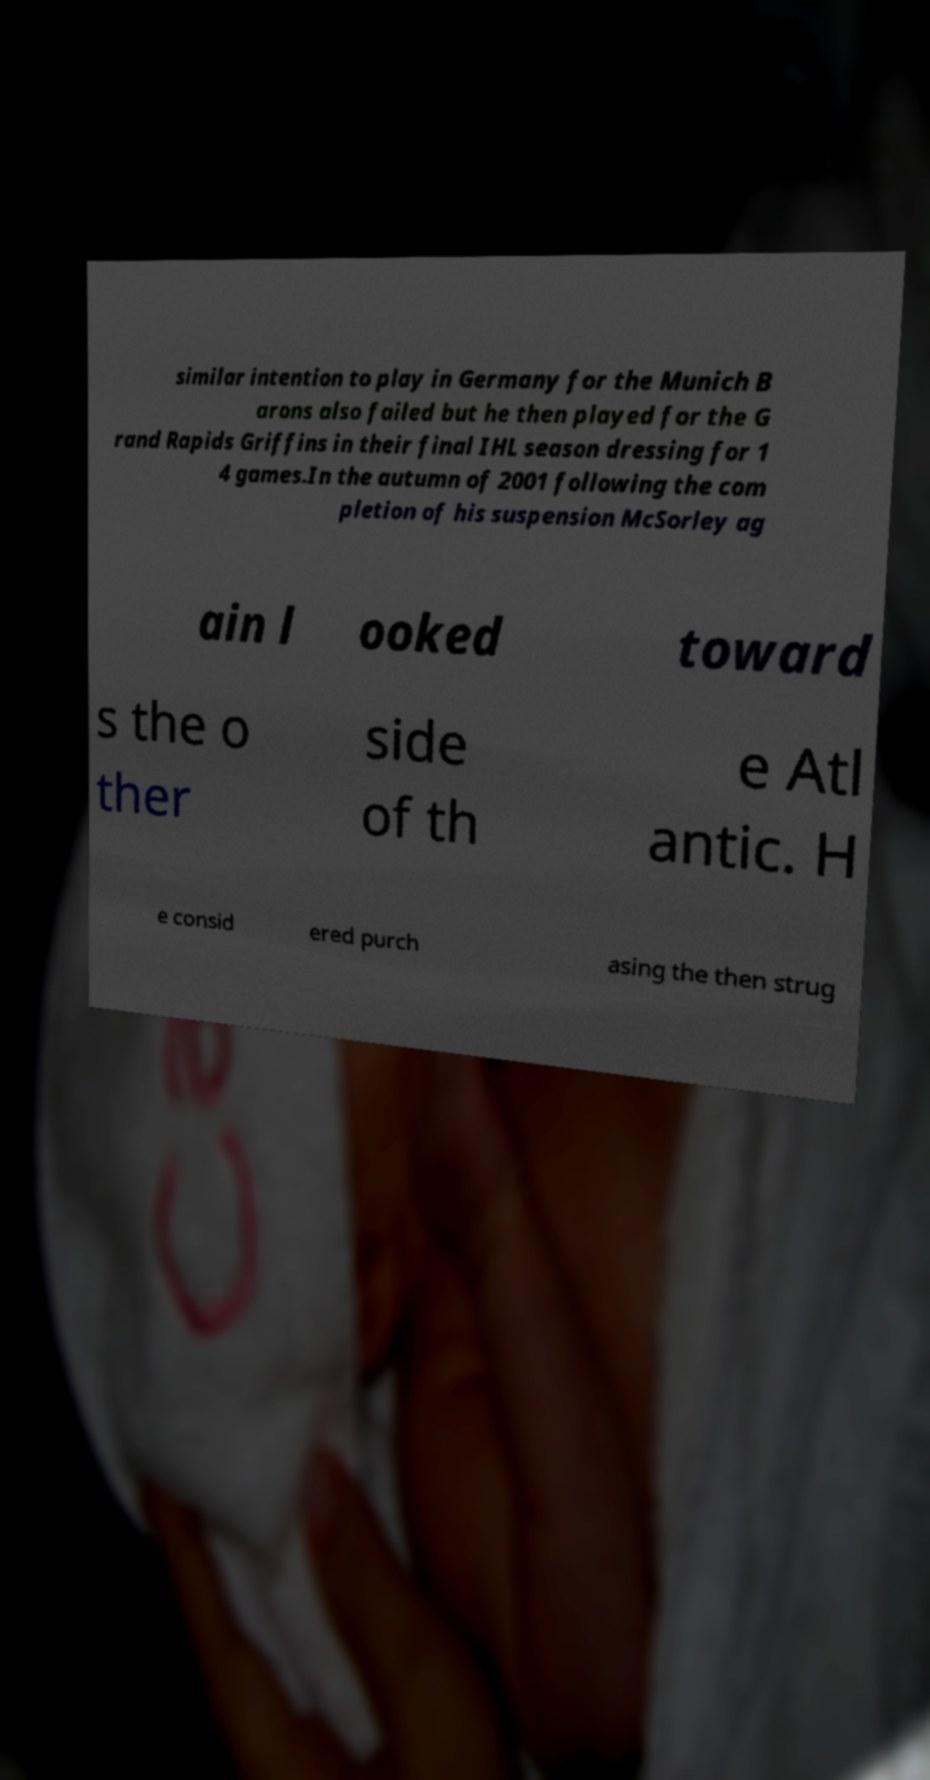There's text embedded in this image that I need extracted. Can you transcribe it verbatim? similar intention to play in Germany for the Munich B arons also failed but he then played for the G rand Rapids Griffins in their final IHL season dressing for 1 4 games.In the autumn of 2001 following the com pletion of his suspension McSorley ag ain l ooked toward s the o ther side of th e Atl antic. H e consid ered purch asing the then strug 